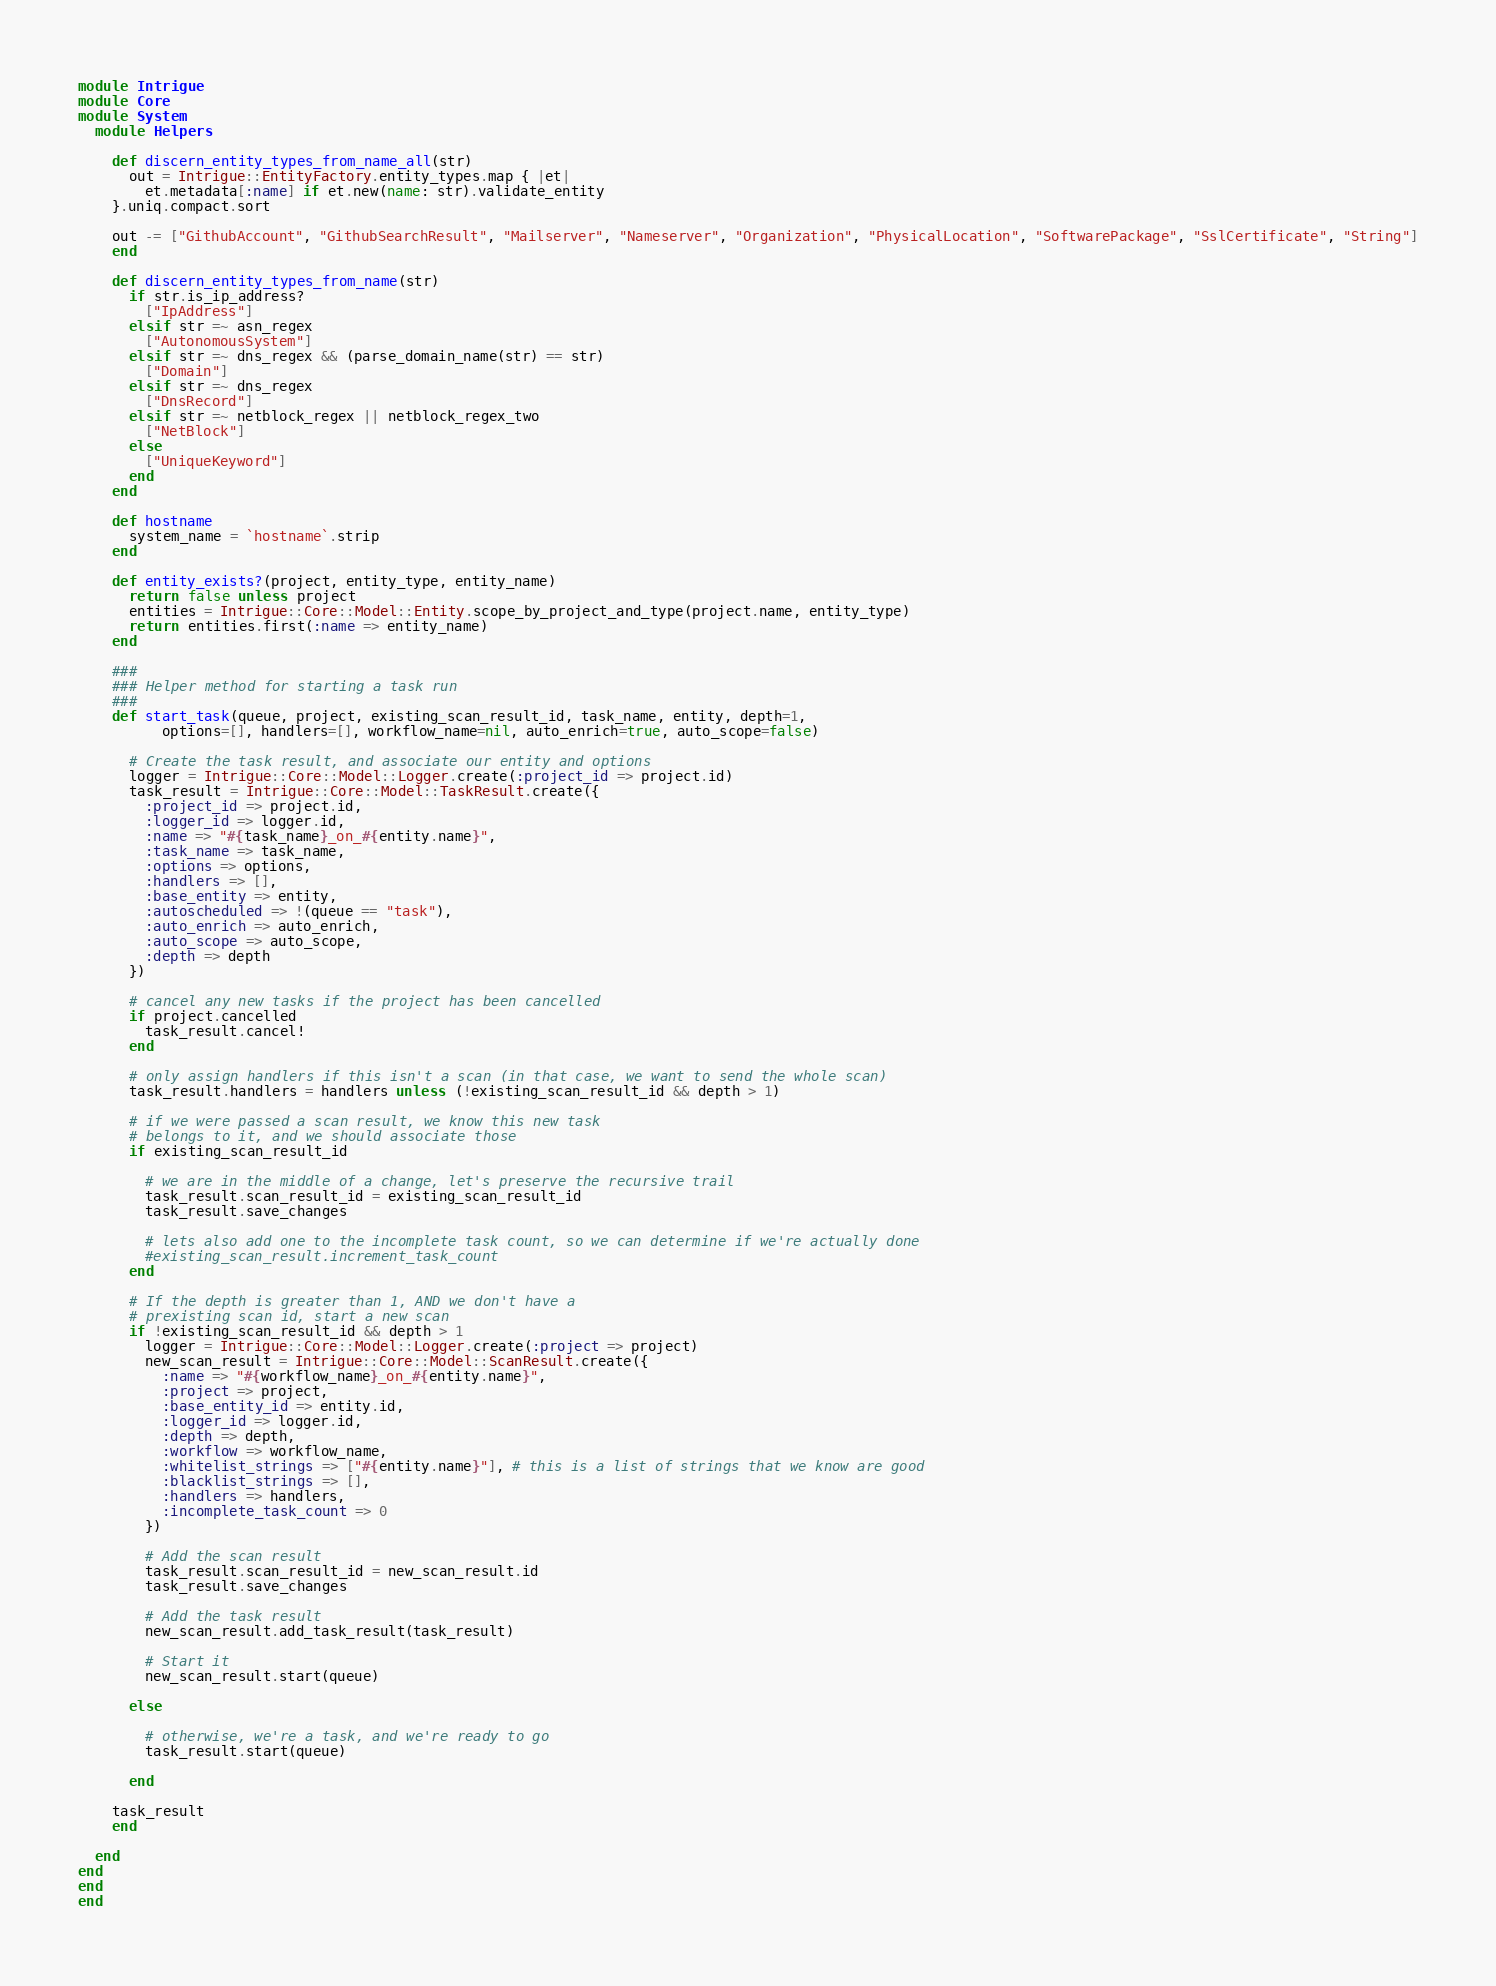Convert code to text. <code><loc_0><loc_0><loc_500><loc_500><_Ruby_>module Intrigue
module Core
module System
  module Helpers

    def discern_entity_types_from_name_all(str)
      out = Intrigue::EntityFactory.entity_types.map { |et|
        et.metadata[:name] if et.new(name: str).validate_entity
    }.uniq.compact.sort

    out -= ["GithubAccount", "GithubSearchResult", "Mailserver", "Nameserver", "Organization", "PhysicalLocation", "SoftwarePackage", "SslCertificate", "String"]
    end

    def discern_entity_types_from_name(str)
      if str.is_ip_address?
        ["IpAddress"]
      elsif str =~ asn_regex
        ["AutonomousSystem"]
      elsif str =~ dns_regex && (parse_domain_name(str) == str)
        ["Domain"]
      elsif str =~ dns_regex
        ["DnsRecord"]
      elsif str =~ netblock_regex || netblock_regex_two
        ["NetBlock"]
      else
        ["UniqueKeyword"]
      end
    end

    def hostname
      system_name = `hostname`.strip
    end

    def entity_exists?(project, entity_type, entity_name)
      return false unless project
      entities = Intrigue::Core::Model::Entity.scope_by_project_and_type(project.name, entity_type)
      return entities.first(:name => entity_name)
    end

    ###
    ### Helper method for starting a task run
    ###
    def start_task(queue, project, existing_scan_result_id, task_name, entity, depth=1,
          options=[], handlers=[], workflow_name=nil, auto_enrich=true, auto_scope=false)

      # Create the task result, and associate our entity and options
      logger = Intrigue::Core::Model::Logger.create(:project_id => project.id)
      task_result = Intrigue::Core::Model::TaskResult.create({
        :project_id => project.id,
        :logger_id => logger.id,
        :name => "#{task_name}_on_#{entity.name}",
        :task_name => task_name,
        :options => options,
        :handlers => [],
        :base_entity => entity,
        :autoscheduled => !(queue == "task"),
        :auto_enrich => auto_enrich,
        :auto_scope => auto_scope,
        :depth => depth
      })

      # cancel any new tasks if the project has been cancelled
      if project.cancelled
        task_result.cancel!
      end

      # only assign handlers if this isn't a scan (in that case, we want to send the whole scan)
      task_result.handlers = handlers unless (!existing_scan_result_id && depth > 1)

      # if we were passed a scan result, we know this new task
      # belongs to it, and we should associate those
      if existing_scan_result_id

        # we are in the middle of a change, let's preserve the recursive trail
        task_result.scan_result_id = existing_scan_result_id
        task_result.save_changes

        # lets also add one to the incomplete task count, so we can determine if we're actually done
        #existing_scan_result.increment_task_count
      end

      # If the depth is greater than 1, AND we don't have a
      # prexisting scan id, start a new scan
      if !existing_scan_result_id && depth > 1
        logger = Intrigue::Core::Model::Logger.create(:project => project)
        new_scan_result = Intrigue::Core::Model::ScanResult.create({
          :name => "#{workflow_name}_on_#{entity.name}",
          :project => project,
          :base_entity_id => entity.id,
          :logger_id => logger.id,
          :depth => depth,
          :workflow => workflow_name,
          :whitelist_strings => ["#{entity.name}"], # this is a list of strings that we know are good
          :blacklist_strings => [],
          :handlers => handlers,
          :incomplete_task_count => 0
        })

        # Add the scan result
        task_result.scan_result_id = new_scan_result.id
        task_result.save_changes

        # Add the task result
        new_scan_result.add_task_result(task_result)

        # Start it
        new_scan_result.start(queue)

      else

        # otherwise, we're a task, and we're ready to go
        task_result.start(queue)

      end

    task_result
    end

  end
end
end
end</code> 